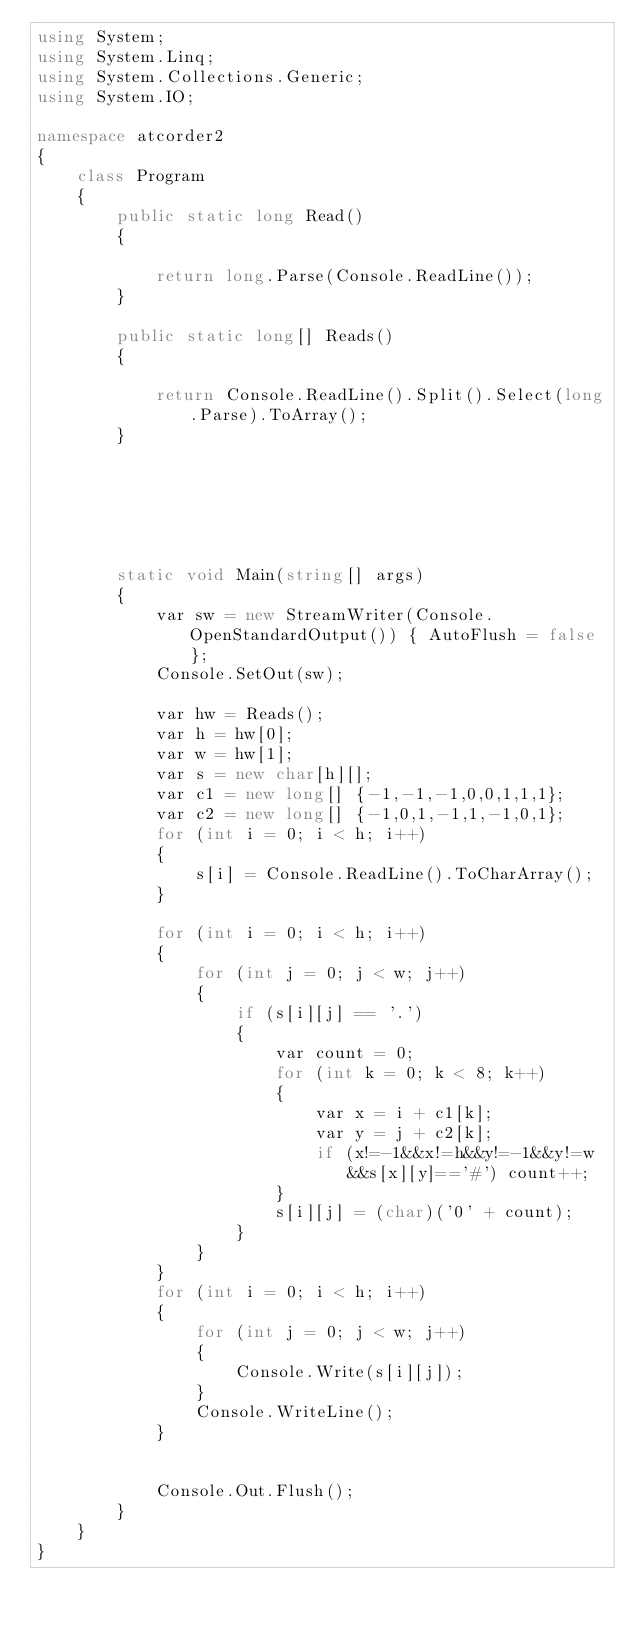<code> <loc_0><loc_0><loc_500><loc_500><_C#_>using System;
using System.Linq;
using System.Collections.Generic;
using System.IO;

namespace atcorder2
{
    class Program
    {
        public static long Read()
        {

            return long.Parse(Console.ReadLine());
        }

        public static long[] Reads()
        {

            return Console.ReadLine().Split().Select(long.Parse).ToArray();
        }

       




        static void Main(string[] args)
        {
            var sw = new StreamWriter(Console.OpenStandardOutput()) { AutoFlush = false };
            Console.SetOut(sw);

            var hw = Reads();
            var h = hw[0];
            var w = hw[1];
            var s = new char[h][];
            var c1 = new long[] {-1,-1,-1,0,0,1,1,1};
            var c2 = new long[] {-1,0,1,-1,1,-1,0,1};
            for (int i = 0; i < h; i++)
            {
                s[i] = Console.ReadLine().ToCharArray();
            }
            
            for (int i = 0; i < h; i++)
            {
                for (int j = 0; j < w; j++)
                {
                    if (s[i][j] == '.')
                    {
                        var count = 0;
                        for (int k = 0; k < 8; k++)
                        {
                            var x = i + c1[k];
                            var y = j + c2[k];
                            if (x!=-1&&x!=h&&y!=-1&&y!=w&&s[x][y]=='#') count++;
                        }
                        s[i][j] = (char)('0' + count);
                    }
                }
            }
            for (int i = 0; i < h; i++)
            {
                for (int j = 0; j < w; j++)
                {
                    Console.Write(s[i][j]);
                }
                Console.WriteLine();
            }


            Console.Out.Flush();
        }
    }
}


</code> 